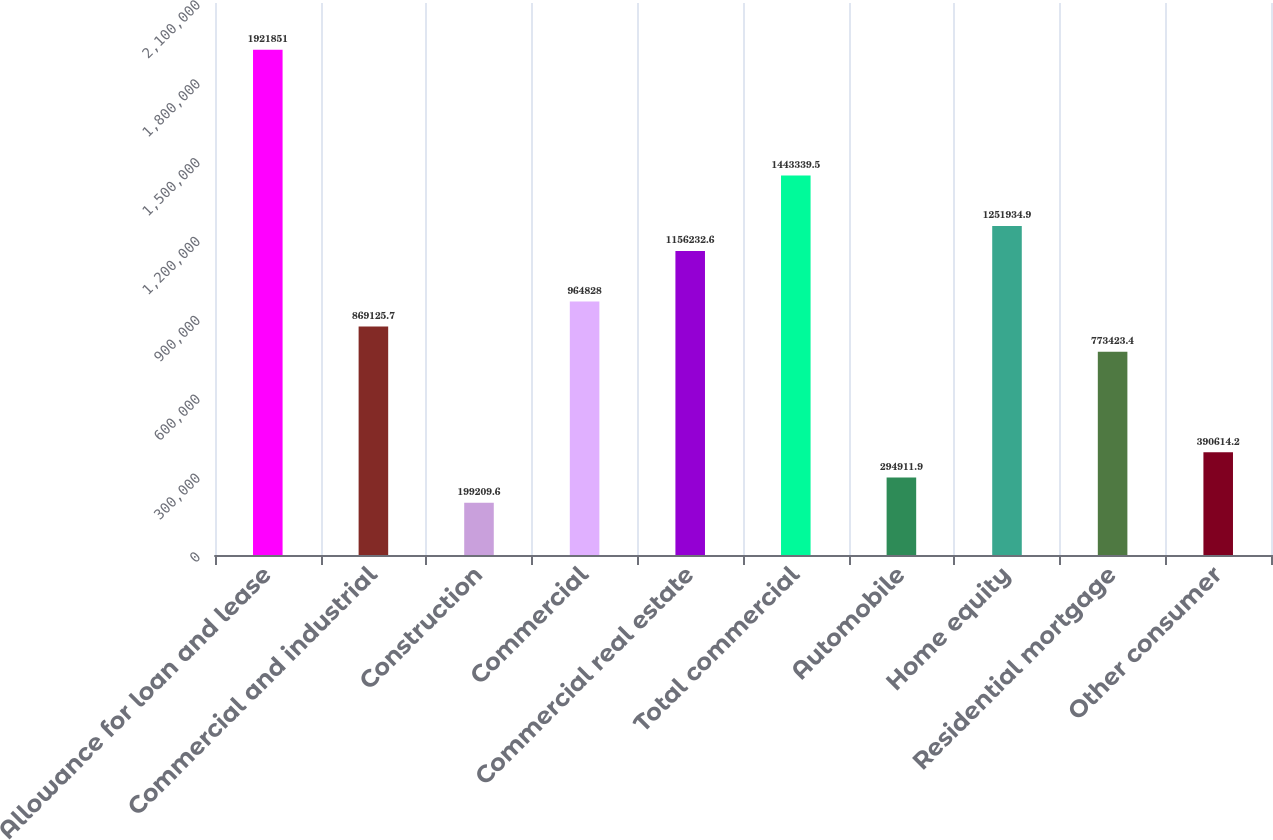<chart> <loc_0><loc_0><loc_500><loc_500><bar_chart><fcel>Allowance for loan and lease<fcel>Commercial and industrial<fcel>Construction<fcel>Commercial<fcel>Commercial real estate<fcel>Total commercial<fcel>Automobile<fcel>Home equity<fcel>Residential mortgage<fcel>Other consumer<nl><fcel>1.92185e+06<fcel>869126<fcel>199210<fcel>964828<fcel>1.15623e+06<fcel>1.44334e+06<fcel>294912<fcel>1.25193e+06<fcel>773423<fcel>390614<nl></chart> 